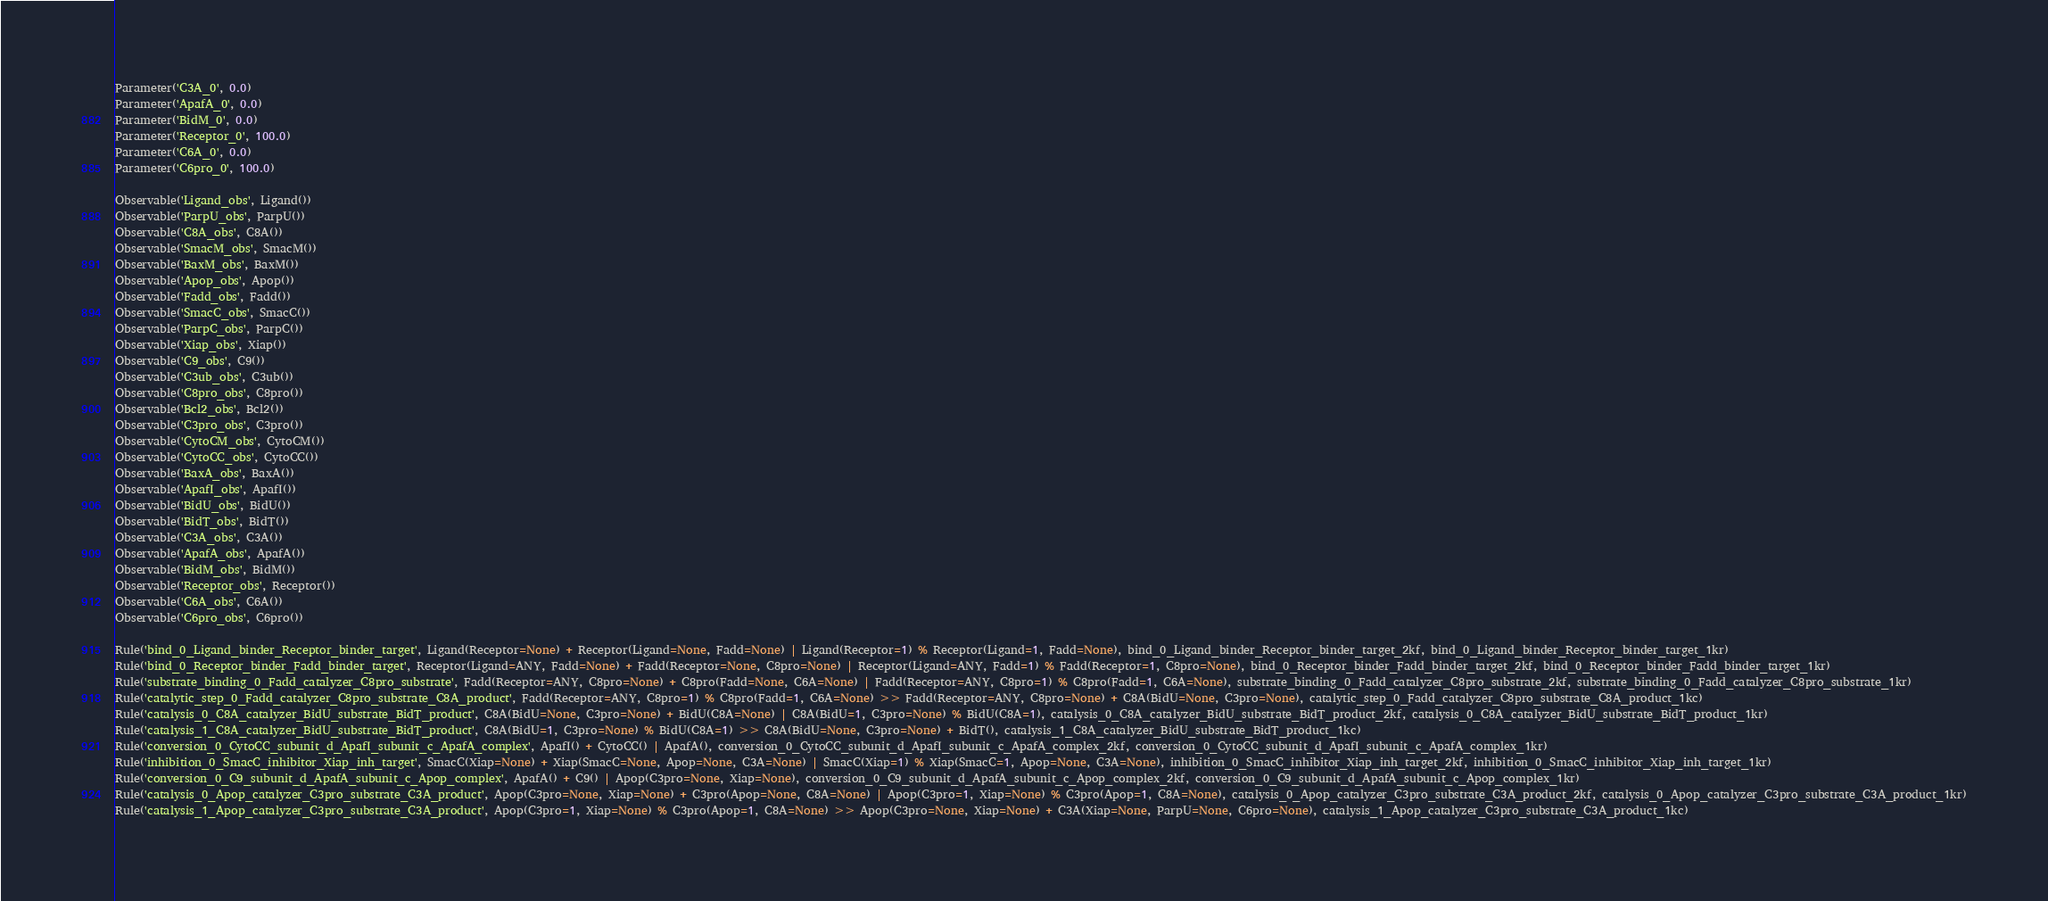<code> <loc_0><loc_0><loc_500><loc_500><_Python_>Parameter('C3A_0', 0.0)
Parameter('ApafA_0', 0.0)
Parameter('BidM_0', 0.0)
Parameter('Receptor_0', 100.0)
Parameter('C6A_0', 0.0)
Parameter('C6pro_0', 100.0)

Observable('Ligand_obs', Ligand())
Observable('ParpU_obs', ParpU())
Observable('C8A_obs', C8A())
Observable('SmacM_obs', SmacM())
Observable('BaxM_obs', BaxM())
Observable('Apop_obs', Apop())
Observable('Fadd_obs', Fadd())
Observable('SmacC_obs', SmacC())
Observable('ParpC_obs', ParpC())
Observable('Xiap_obs', Xiap())
Observable('C9_obs', C9())
Observable('C3ub_obs', C3ub())
Observable('C8pro_obs', C8pro())
Observable('Bcl2_obs', Bcl2())
Observable('C3pro_obs', C3pro())
Observable('CytoCM_obs', CytoCM())
Observable('CytoCC_obs', CytoCC())
Observable('BaxA_obs', BaxA())
Observable('ApafI_obs', ApafI())
Observable('BidU_obs', BidU())
Observable('BidT_obs', BidT())
Observable('C3A_obs', C3A())
Observable('ApafA_obs', ApafA())
Observable('BidM_obs', BidM())
Observable('Receptor_obs', Receptor())
Observable('C6A_obs', C6A())
Observable('C6pro_obs', C6pro())

Rule('bind_0_Ligand_binder_Receptor_binder_target', Ligand(Receptor=None) + Receptor(Ligand=None, Fadd=None) | Ligand(Receptor=1) % Receptor(Ligand=1, Fadd=None), bind_0_Ligand_binder_Receptor_binder_target_2kf, bind_0_Ligand_binder_Receptor_binder_target_1kr)
Rule('bind_0_Receptor_binder_Fadd_binder_target', Receptor(Ligand=ANY, Fadd=None) + Fadd(Receptor=None, C8pro=None) | Receptor(Ligand=ANY, Fadd=1) % Fadd(Receptor=1, C8pro=None), bind_0_Receptor_binder_Fadd_binder_target_2kf, bind_0_Receptor_binder_Fadd_binder_target_1kr)
Rule('substrate_binding_0_Fadd_catalyzer_C8pro_substrate', Fadd(Receptor=ANY, C8pro=None) + C8pro(Fadd=None, C6A=None) | Fadd(Receptor=ANY, C8pro=1) % C8pro(Fadd=1, C6A=None), substrate_binding_0_Fadd_catalyzer_C8pro_substrate_2kf, substrate_binding_0_Fadd_catalyzer_C8pro_substrate_1kr)
Rule('catalytic_step_0_Fadd_catalyzer_C8pro_substrate_C8A_product', Fadd(Receptor=ANY, C8pro=1) % C8pro(Fadd=1, C6A=None) >> Fadd(Receptor=ANY, C8pro=None) + C8A(BidU=None, C3pro=None), catalytic_step_0_Fadd_catalyzer_C8pro_substrate_C8A_product_1kc)
Rule('catalysis_0_C8A_catalyzer_BidU_substrate_BidT_product', C8A(BidU=None, C3pro=None) + BidU(C8A=None) | C8A(BidU=1, C3pro=None) % BidU(C8A=1), catalysis_0_C8A_catalyzer_BidU_substrate_BidT_product_2kf, catalysis_0_C8A_catalyzer_BidU_substrate_BidT_product_1kr)
Rule('catalysis_1_C8A_catalyzer_BidU_substrate_BidT_product', C8A(BidU=1, C3pro=None) % BidU(C8A=1) >> C8A(BidU=None, C3pro=None) + BidT(), catalysis_1_C8A_catalyzer_BidU_substrate_BidT_product_1kc)
Rule('conversion_0_CytoCC_subunit_d_ApafI_subunit_c_ApafA_complex', ApafI() + CytoCC() | ApafA(), conversion_0_CytoCC_subunit_d_ApafI_subunit_c_ApafA_complex_2kf, conversion_0_CytoCC_subunit_d_ApafI_subunit_c_ApafA_complex_1kr)
Rule('inhibition_0_SmacC_inhibitor_Xiap_inh_target', SmacC(Xiap=None) + Xiap(SmacC=None, Apop=None, C3A=None) | SmacC(Xiap=1) % Xiap(SmacC=1, Apop=None, C3A=None), inhibition_0_SmacC_inhibitor_Xiap_inh_target_2kf, inhibition_0_SmacC_inhibitor_Xiap_inh_target_1kr)
Rule('conversion_0_C9_subunit_d_ApafA_subunit_c_Apop_complex', ApafA() + C9() | Apop(C3pro=None, Xiap=None), conversion_0_C9_subunit_d_ApafA_subunit_c_Apop_complex_2kf, conversion_0_C9_subunit_d_ApafA_subunit_c_Apop_complex_1kr)
Rule('catalysis_0_Apop_catalyzer_C3pro_substrate_C3A_product', Apop(C3pro=None, Xiap=None) + C3pro(Apop=None, C8A=None) | Apop(C3pro=1, Xiap=None) % C3pro(Apop=1, C8A=None), catalysis_0_Apop_catalyzer_C3pro_substrate_C3A_product_2kf, catalysis_0_Apop_catalyzer_C3pro_substrate_C3A_product_1kr)
Rule('catalysis_1_Apop_catalyzer_C3pro_substrate_C3A_product', Apop(C3pro=1, Xiap=None) % C3pro(Apop=1, C8A=None) >> Apop(C3pro=None, Xiap=None) + C3A(Xiap=None, ParpU=None, C6pro=None), catalysis_1_Apop_catalyzer_C3pro_substrate_C3A_product_1kc)</code> 